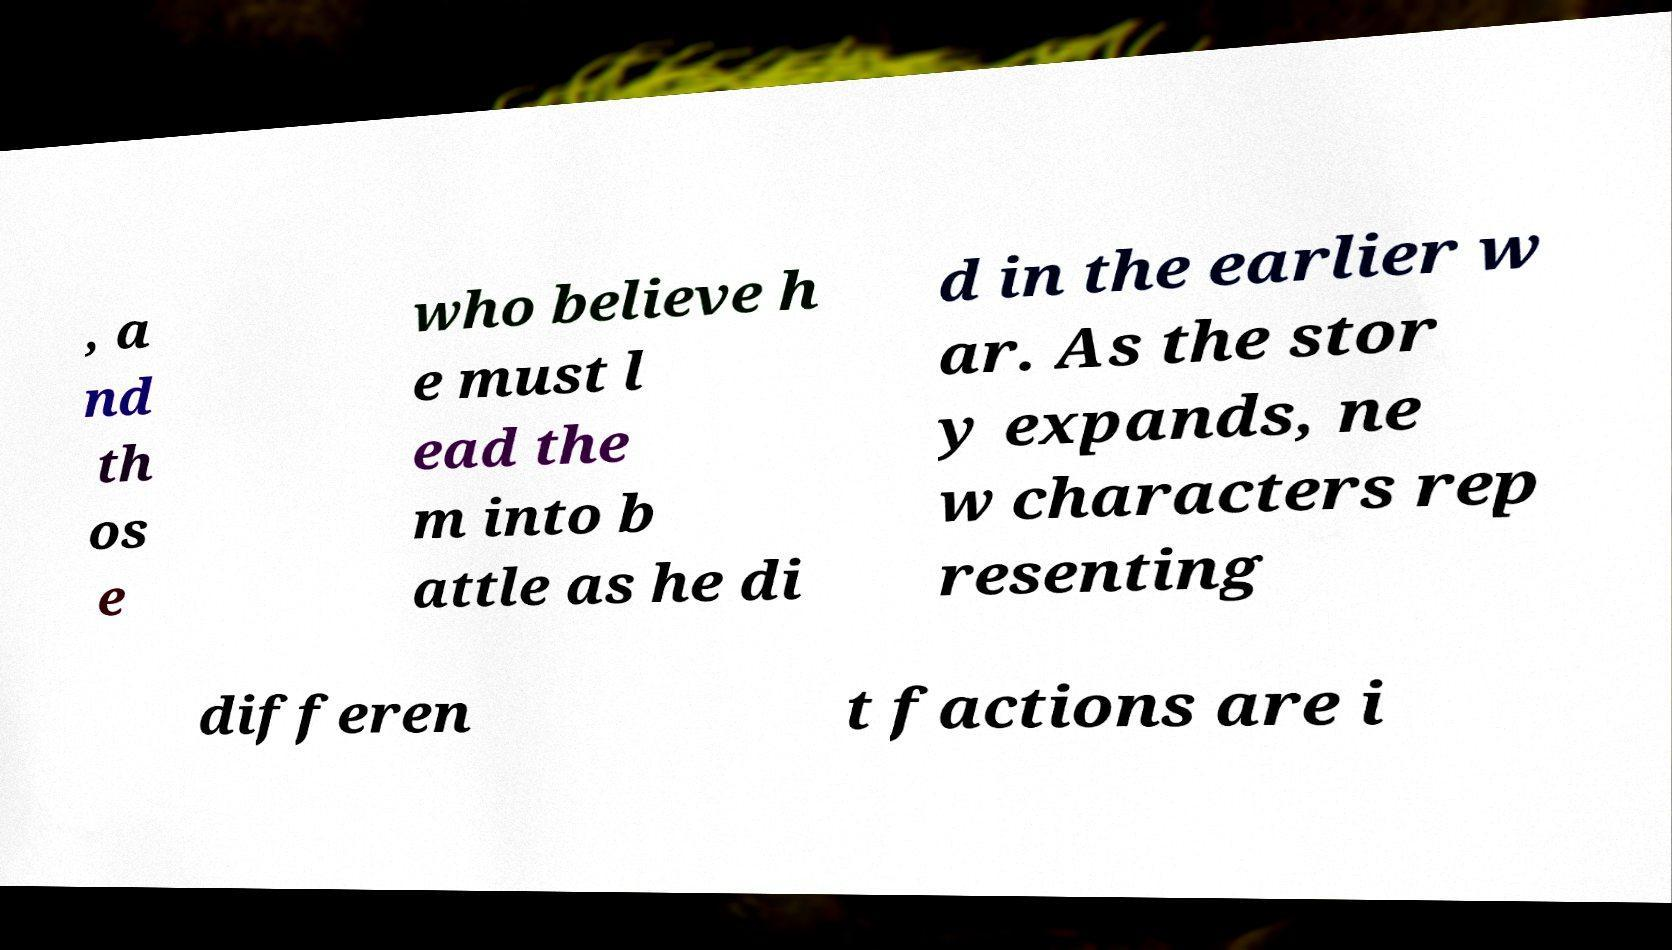Could you assist in decoding the text presented in this image and type it out clearly? , a nd th os e who believe h e must l ead the m into b attle as he di d in the earlier w ar. As the stor y expands, ne w characters rep resenting differen t factions are i 